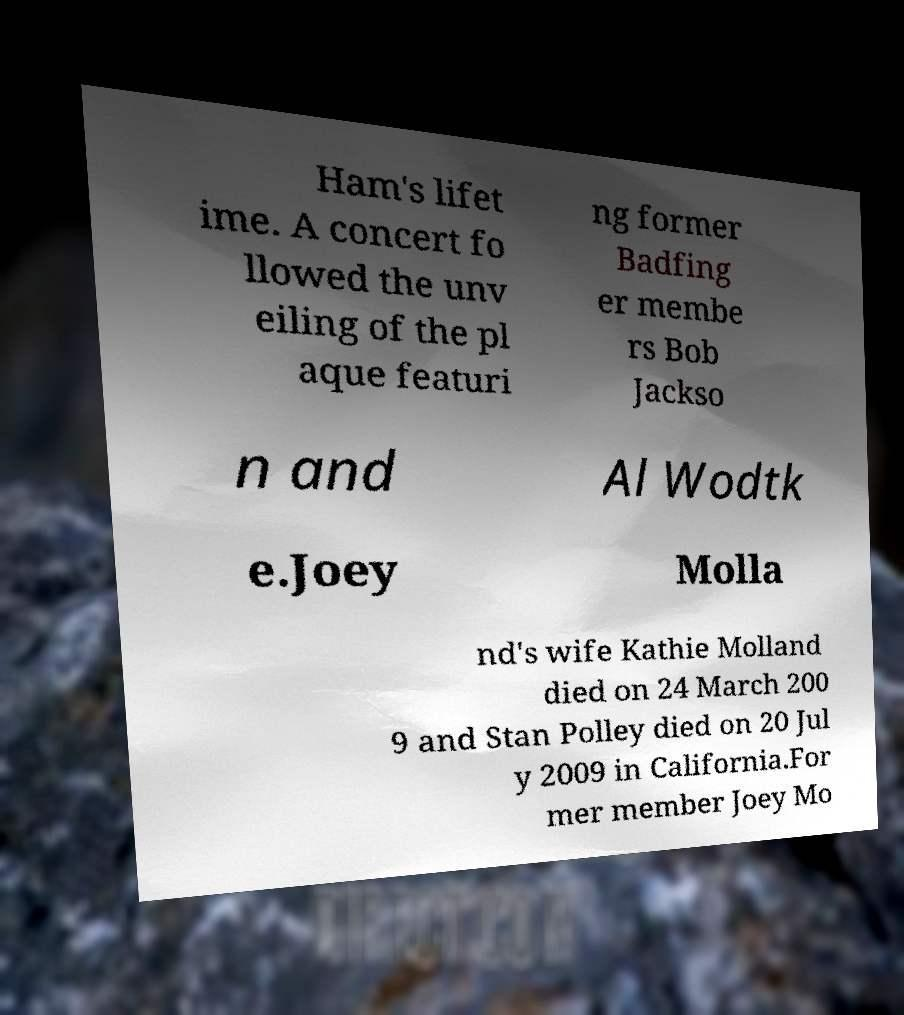For documentation purposes, I need the text within this image transcribed. Could you provide that? Ham's lifet ime. A concert fo llowed the unv eiling of the pl aque featuri ng former Badfing er membe rs Bob Jackso n and Al Wodtk e.Joey Molla nd's wife Kathie Molland died on 24 March 200 9 and Stan Polley died on 20 Jul y 2009 in California.For mer member Joey Mo 